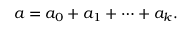Convert formula to latex. <formula><loc_0><loc_0><loc_500><loc_500>a = a _ { 0 } + a _ { 1 } + \cdots + a _ { k } .</formula> 